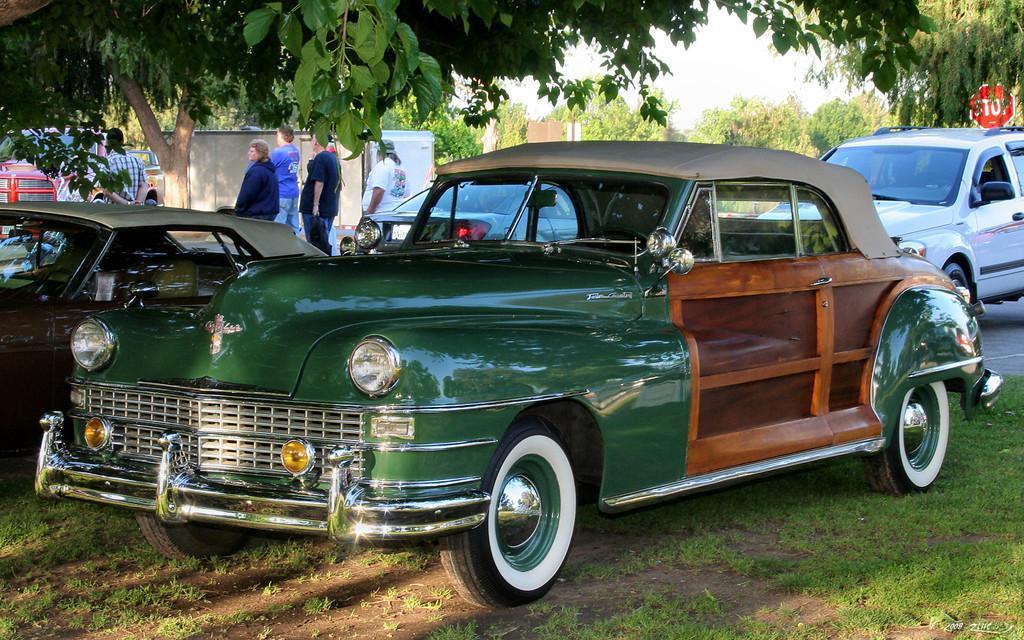Can you describe this image briefly? In this image in the center there are cars on the road and there's grass on the ground. In the background there are trees, there are persons standing and there is a board with some text written on it which is red in colour and the sky is cloudy. 